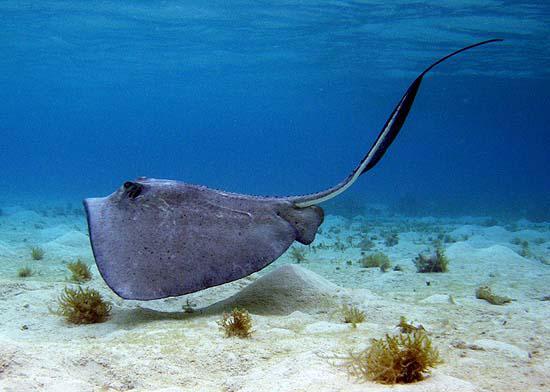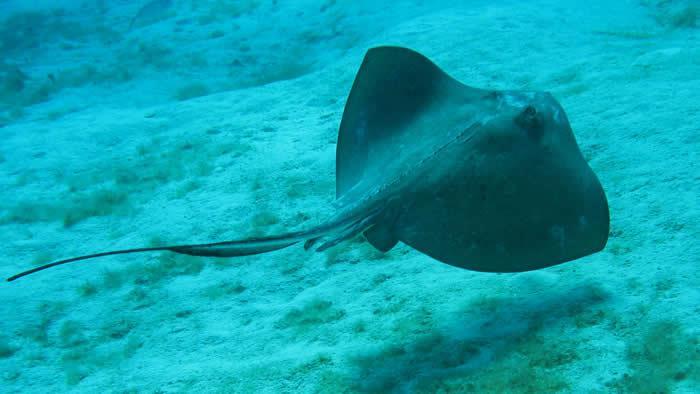The first image is the image on the left, the second image is the image on the right. For the images displayed, is the sentence "A single ray is sitting on the sandy bottom in the image on the left." factually correct? Answer yes or no. No. 